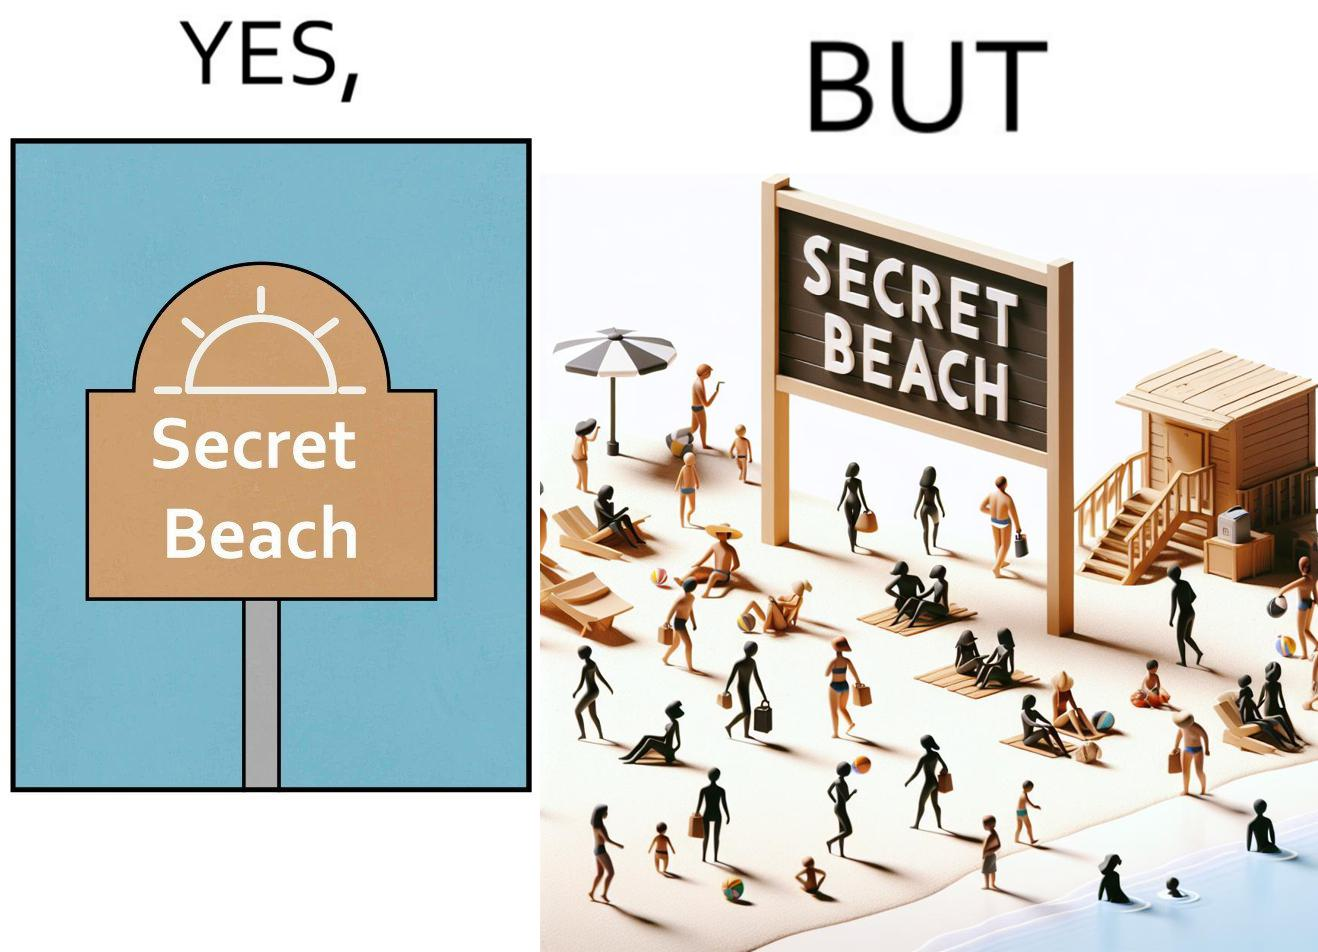Describe what you see in the left and right parts of this image. In the left part of the image: A board with "Secret Beach" written on it. In the right part of the image: People in a beach, having a board with "Secret Beach" written on it at its entrance. 